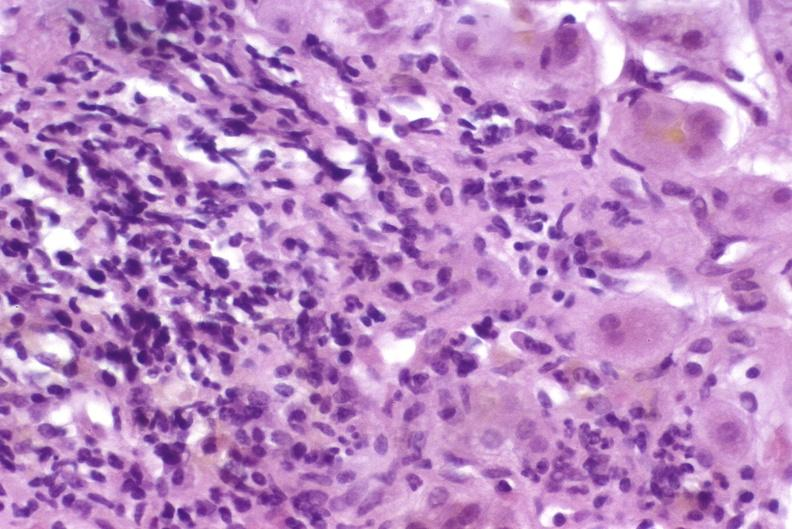what is present?
Answer the question using a single word or phrase. Liver 